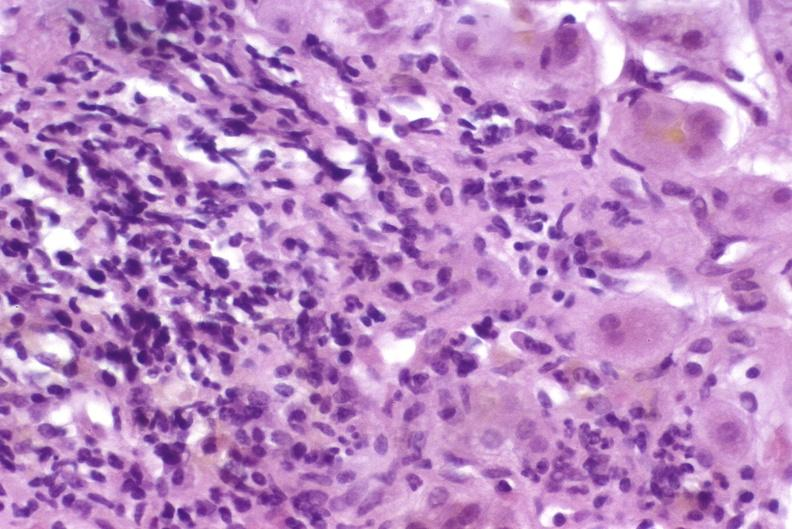what is present?
Answer the question using a single word or phrase. Liver 